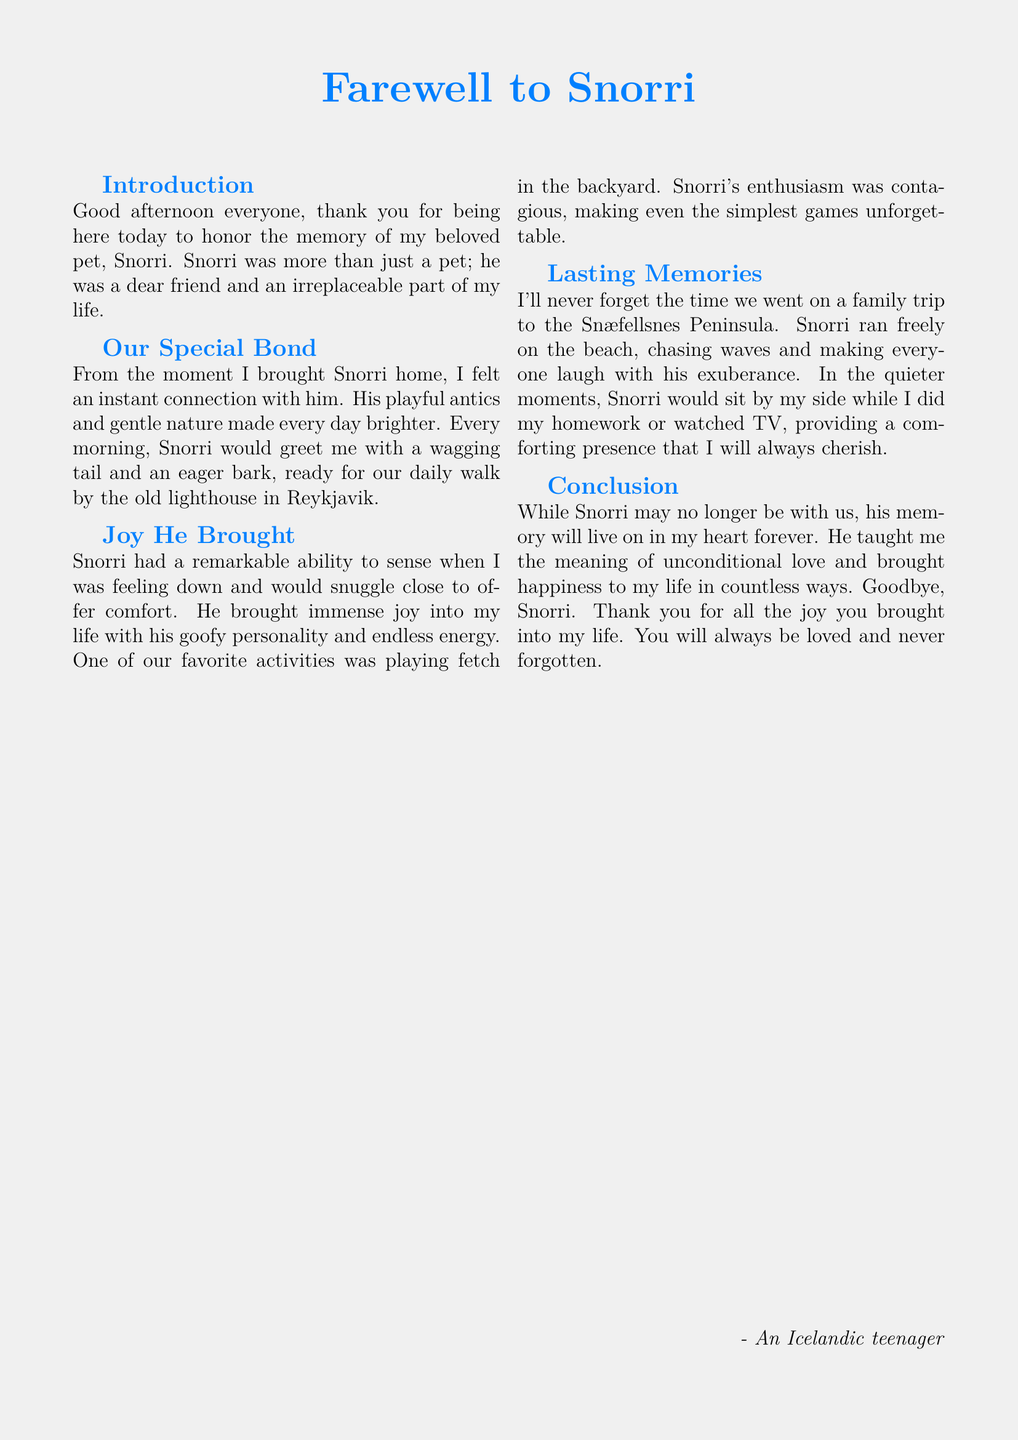What is the name of the pet being honored? The name of the pet is mentioned in the title and throughout the document as Snorri.
Answer: Snorri What kind of animal was Snorri? While the specific type of animal is not explicitly stated, the context suggests that Snorri is a dog due to references to fetching and barking.
Answer: Dog Where did the daily walks take place? The document specifies that the walks occurred by the old lighthouse in Reykjavik.
Answer: Old lighthouse in Reykjavik What activity brought immense joy to the speaker? The document mentions playing fetch in the backyard as an activity that brought joy.
Answer: Playing fetch in the backyard What lesson did Snorri teach the speaker? The document highlights that Snorri taught the meaning of unconditional love.
Answer: Unconditional love Which location did the family visit with Snorri? Snæfellsnes Peninsula is the location mentioned in the document where the family trip took place.
Answer: Snæfellsnes Peninsula In what year was Snorri celebrated in this eulogy? The document does not specify a year for Snorri's celebration; it focuses on shared memories.
Answer: Not specified What color is used in the document’s title? The color mentioned for the title text is icelandicblue.
Answer: Icelandic blue 